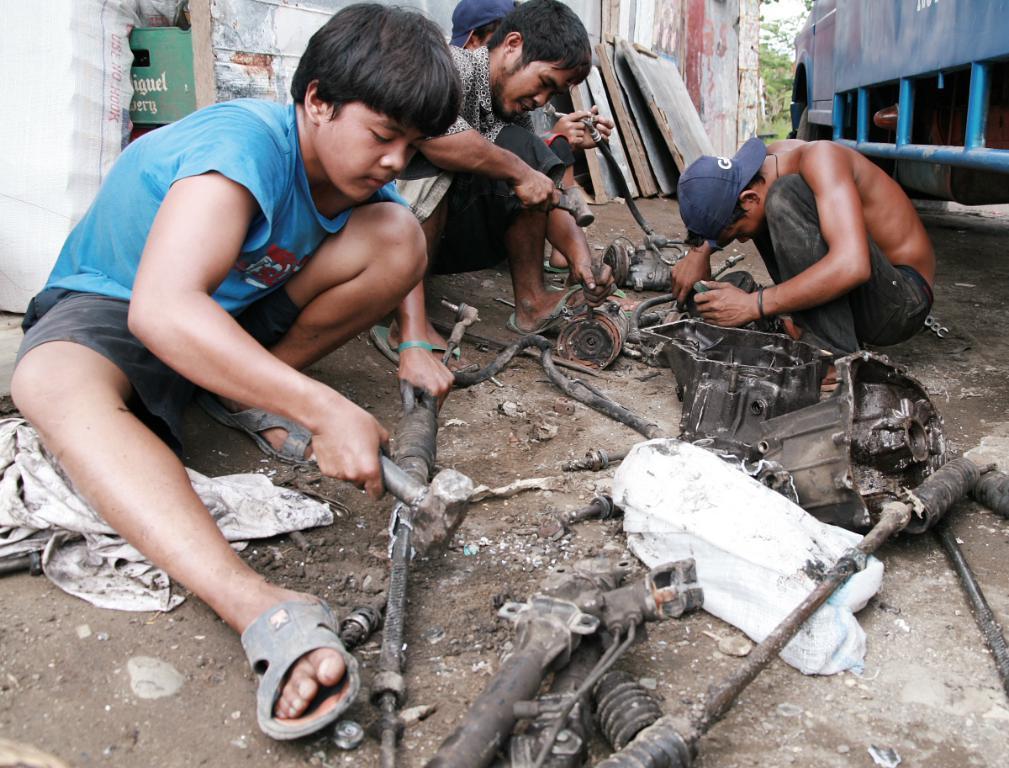Can you describe this image briefly? In this image there are four persons sitting and repairing something, and in the background there is a vehicle , there are trees and some other objects. 